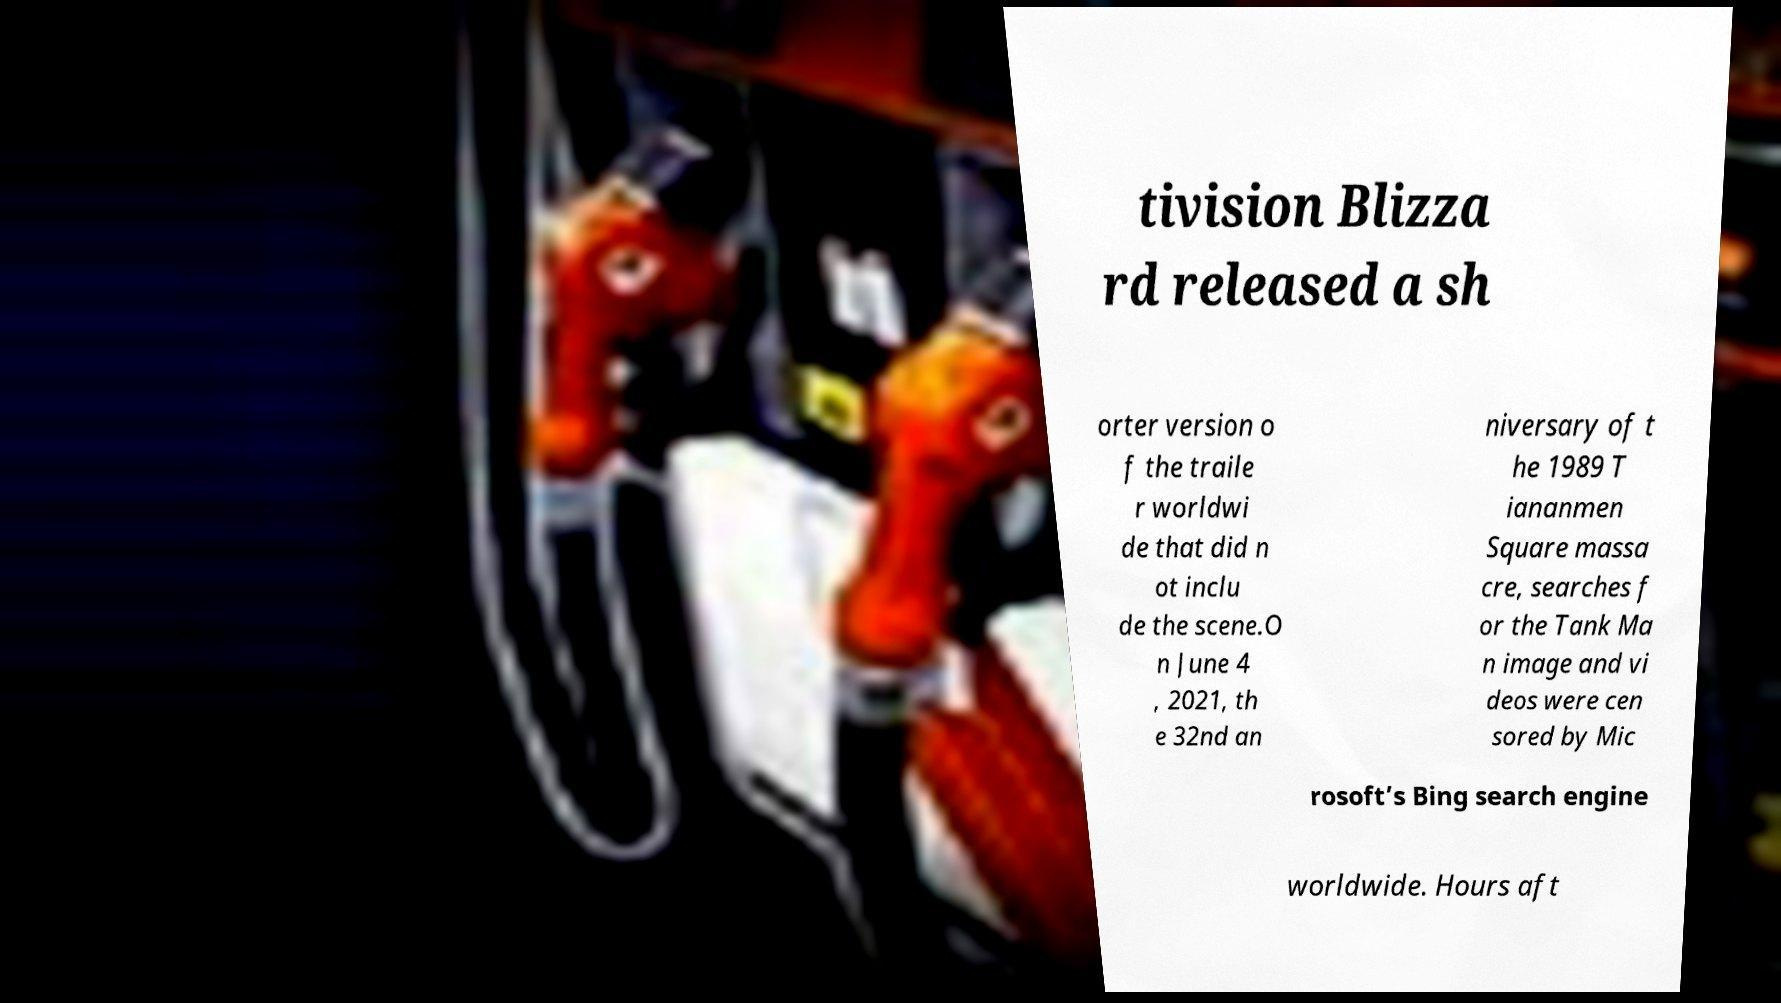There's text embedded in this image that I need extracted. Can you transcribe it verbatim? tivision Blizza rd released a sh orter version o f the traile r worldwi de that did n ot inclu de the scene.O n June 4 , 2021, th e 32nd an niversary of t he 1989 T iananmen Square massa cre, searches f or the Tank Ma n image and vi deos were cen sored by Mic rosoft’s Bing search engine worldwide. Hours aft 